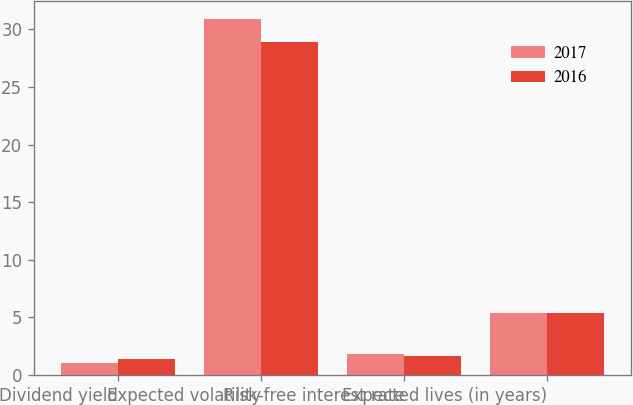Convert chart. <chart><loc_0><loc_0><loc_500><loc_500><stacked_bar_chart><ecel><fcel>Dividend yield<fcel>Expected volatility<fcel>Risk-free interest rate<fcel>Expected lives (in years)<nl><fcel>2017<fcel>1.03<fcel>30.91<fcel>1.81<fcel>5.4<nl><fcel>2016<fcel>1.41<fcel>28.85<fcel>1.65<fcel>5.4<nl></chart> 